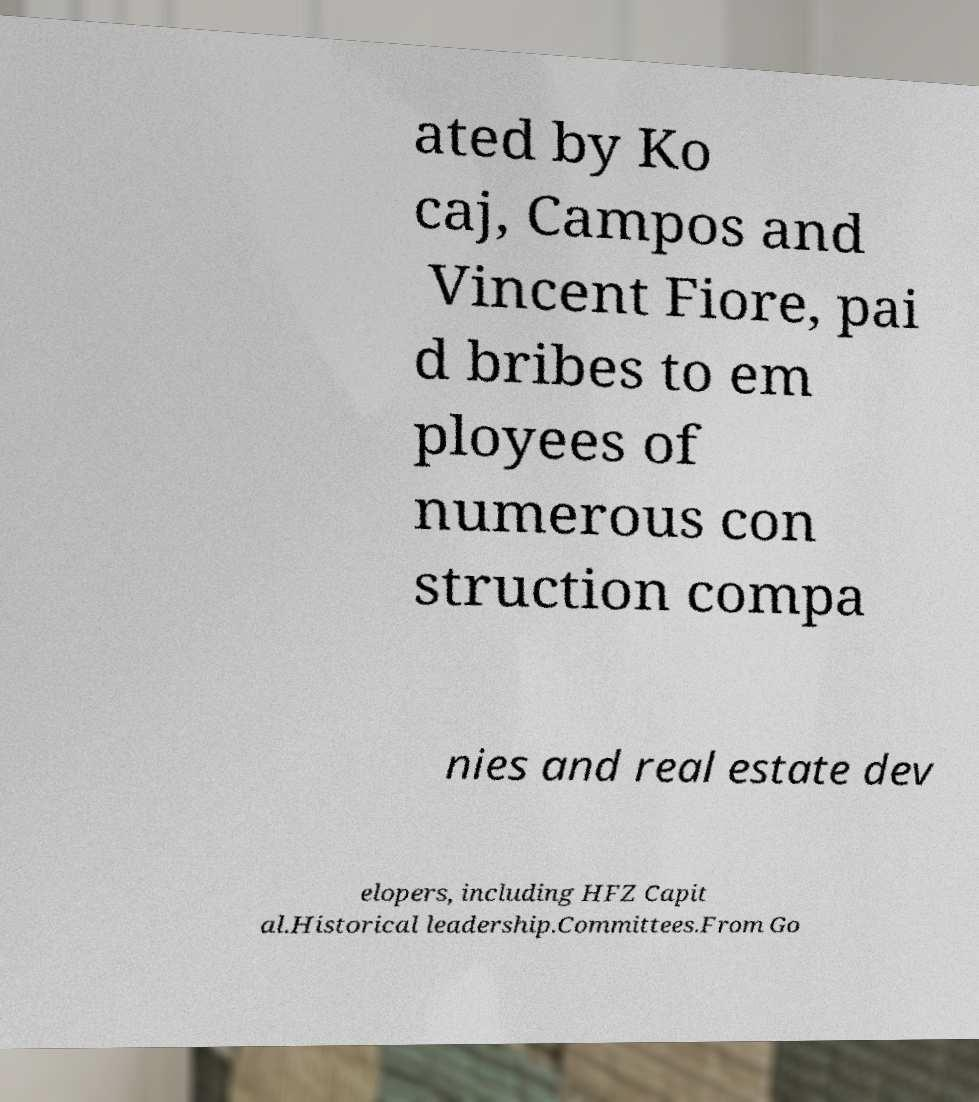Could you assist in decoding the text presented in this image and type it out clearly? ated by Ko caj, Campos and Vincent Fiore, pai d bribes to em ployees of numerous con struction compa nies and real estate dev elopers, including HFZ Capit al.Historical leadership.Committees.From Go 